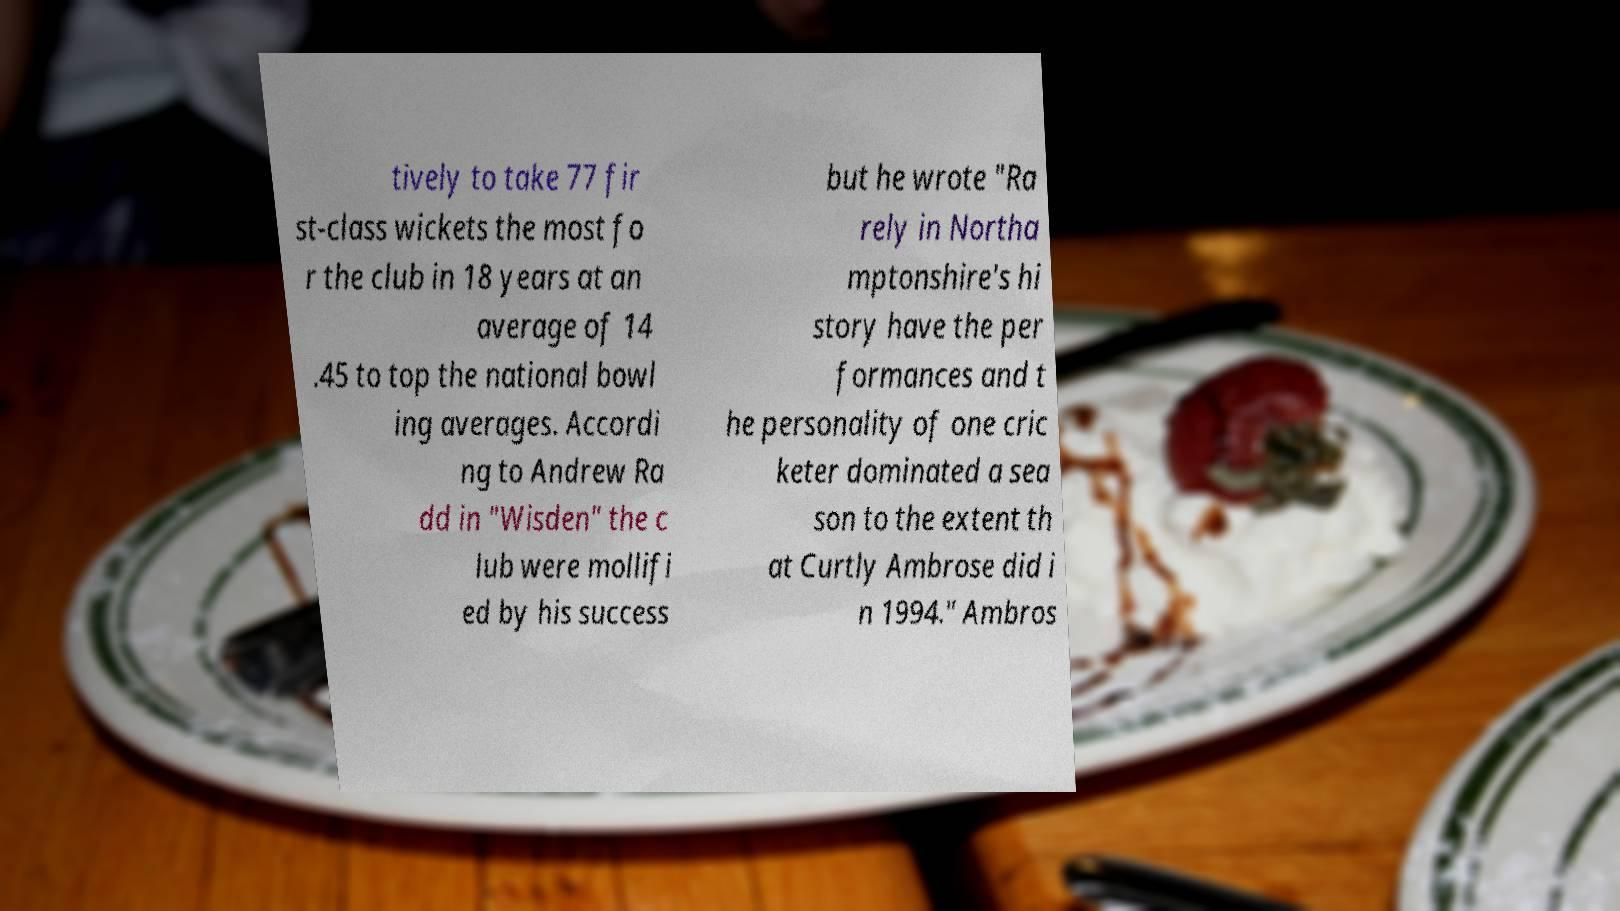For documentation purposes, I need the text within this image transcribed. Could you provide that? tively to take 77 fir st-class wickets the most fo r the club in 18 years at an average of 14 .45 to top the national bowl ing averages. Accordi ng to Andrew Ra dd in "Wisden" the c lub were mollifi ed by his success but he wrote "Ra rely in Northa mptonshire's hi story have the per formances and t he personality of one cric keter dominated a sea son to the extent th at Curtly Ambrose did i n 1994." Ambros 